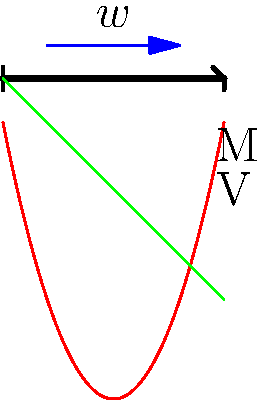A simply supported beam of length 10 meters is subjected to a uniformly distributed load $w$ kN/m along its entire length. Analyze the stress distribution in the beam and determine the maximum bending moment. How does this loading condition affect the overall stress pattern compared to a point load at the center? To analyze the stress distribution and determine the maximum bending moment, we'll follow these steps:

1. Reaction forces:
   Due to symmetry, the reaction forces at both supports are equal:
   $$R_A = R_B = \frac{wL}{2} = \frac{w \cdot 10}{2} = 5w \text{ kN}$$

2. Shear force equation:
   $$V(x) = R_A - wx = 5w - wx$$

3. Bending moment equation:
   $$M(x) = R_A x - \frac{wx^2}{2} = 5wx - \frac{wx^2}{2}$$

4. Maximum bending moment:
   The maximum bending moment occurs at the center of the beam (x = 5 m):
   $$M_{max} = M(5) = 5w(5) - \frac{w(5)^2}{2} = 25w - \frac{25w}{2} = \frac{25w}{2} \text{ kN·m}$$

5. Stress distribution:
   The normal stress due to bending is given by:
   $$\sigma = \frac{My}{I}$$
   where M is the bending moment, y is the distance from the neutral axis, and I is the moment of inertia.

6. Comparison to point load:
   For a point load P at the center:
   $$M_{max} = \frac{PL}{4}$$
   The distributed load creates a parabolic bending moment diagram, while a point load creates a triangular diagram. The distributed load results in a more uniform stress distribution along the beam compared to the concentrated stress at the center with a point load.
Answer: Maximum bending moment: $\frac{25w}{2}$ kN·m; Distributed load creates more uniform stress distribution than point load. 